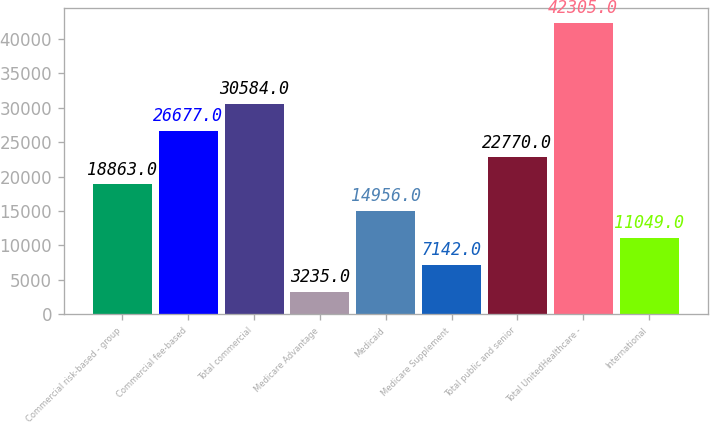Convert chart to OTSL. <chart><loc_0><loc_0><loc_500><loc_500><bar_chart><fcel>Commercial risk-based - group<fcel>Commercial fee-based<fcel>Total commercial<fcel>Medicare Advantage<fcel>Medicaid<fcel>Medicare Supplement<fcel>Total public and senior<fcel>Total UnitedHealthcare -<fcel>International<nl><fcel>18863<fcel>26677<fcel>30584<fcel>3235<fcel>14956<fcel>7142<fcel>22770<fcel>42305<fcel>11049<nl></chart> 